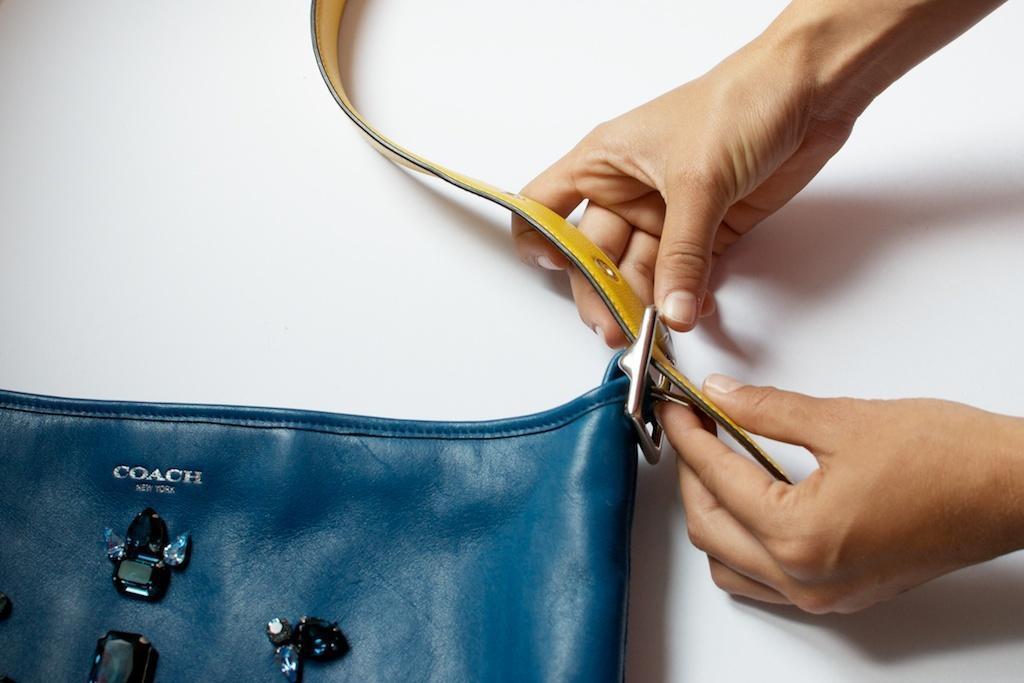Please provide a concise description of this image. This is the picture of a person holding a belt in front of this person there is a bag in blue color. Background of this bag and person is in white color. 